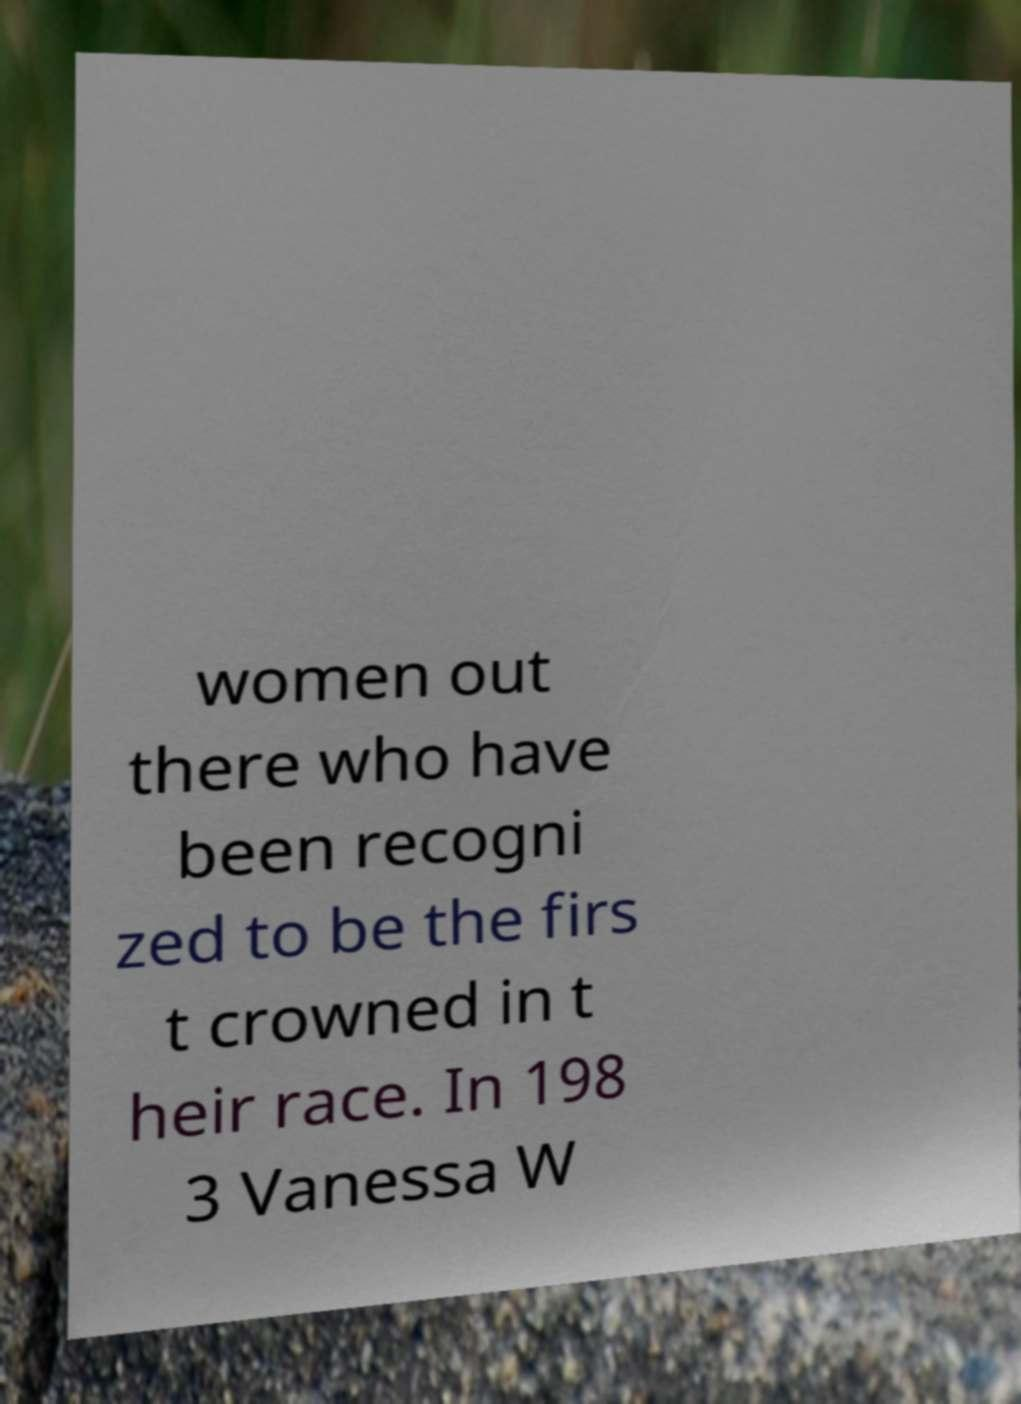Can you accurately transcribe the text from the provided image for me? women out there who have been recogni zed to be the firs t crowned in t heir race. In 198 3 Vanessa W 